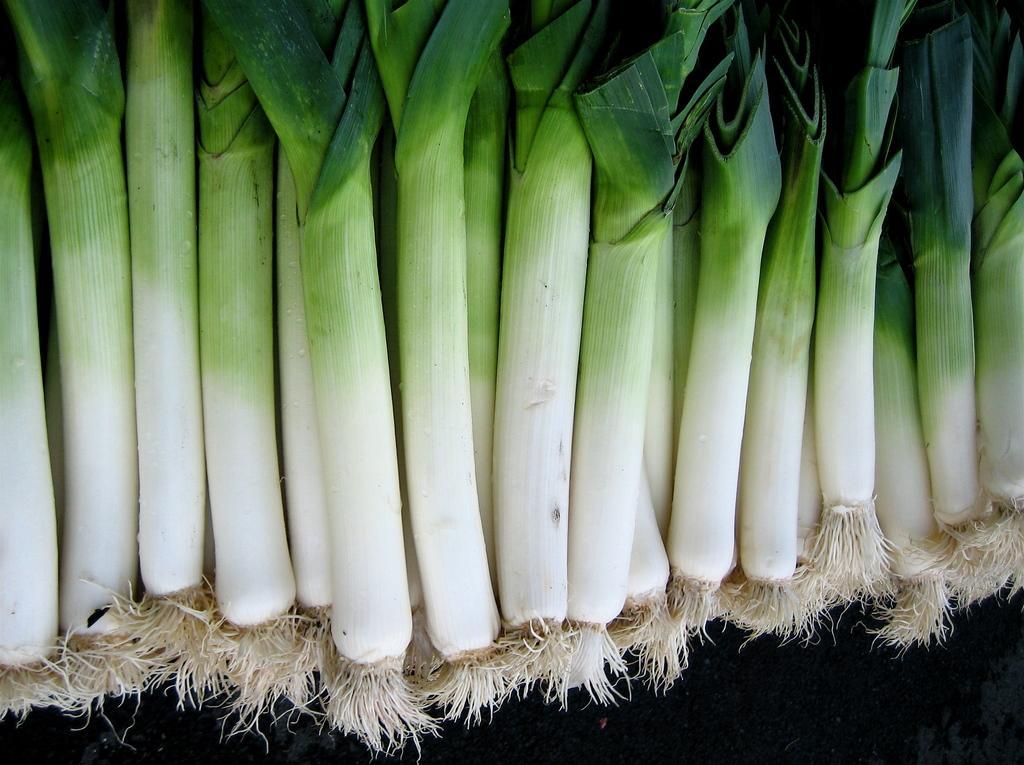Could you give a brief overview of what you see in this image? In the image we can see spring onions on the dark surface. 